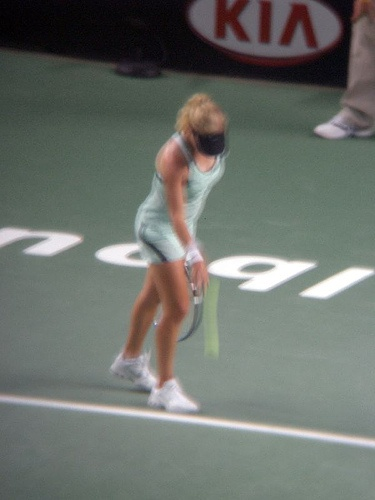Describe the objects in this image and their specific colors. I can see people in black, gray, darkgray, and brown tones, people in black, gray, darkgray, and maroon tones, people in black tones, tennis racket in black and gray tones, and sports ball in darkgray, gray, and black tones in this image. 